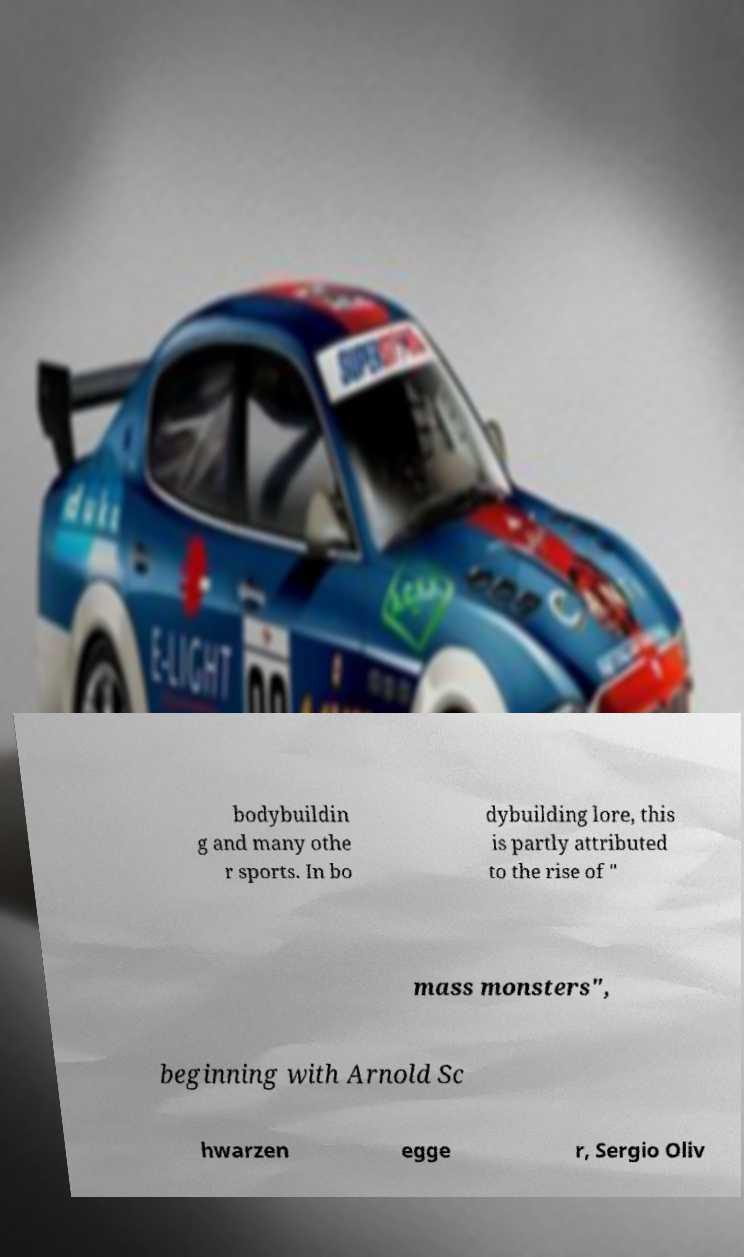Can you read and provide the text displayed in the image?This photo seems to have some interesting text. Can you extract and type it out for me? bodybuildin g and many othe r sports. In bo dybuilding lore, this is partly attributed to the rise of " mass monsters", beginning with Arnold Sc hwarzen egge r, Sergio Oliv 